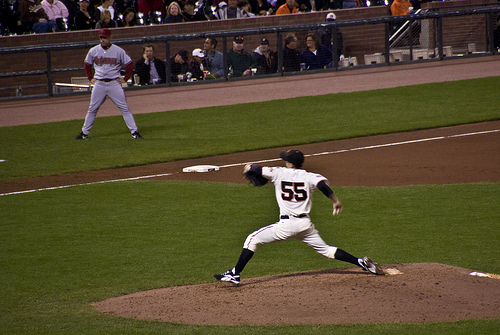Is there a fence that is not black? No, all parts of the fence visible in the image are uniformly black. 